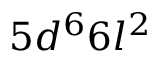Convert formula to latex. <formula><loc_0><loc_0><loc_500><loc_500>5 d ^ { 6 } 6 l ^ { 2 }</formula> 